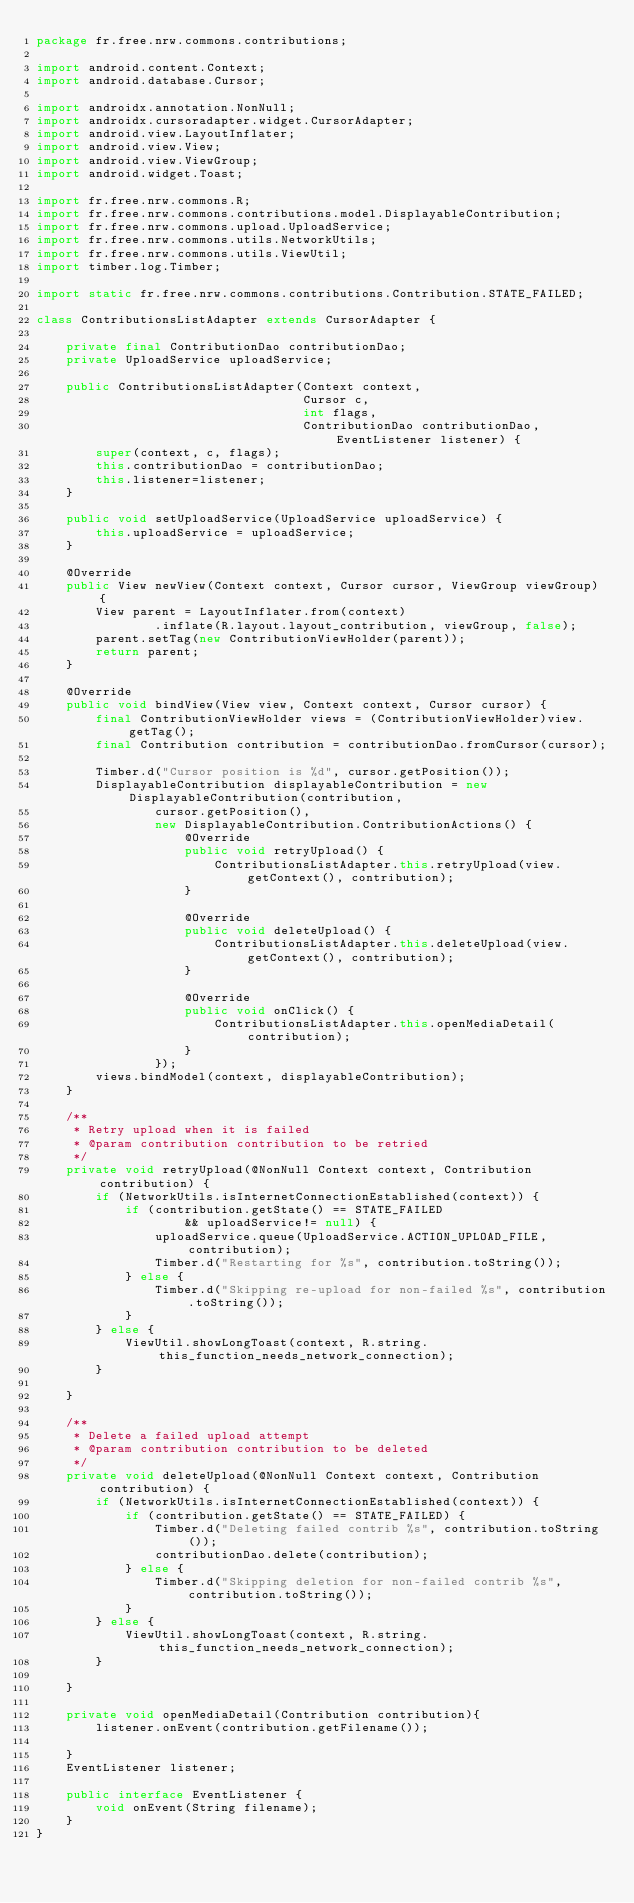<code> <loc_0><loc_0><loc_500><loc_500><_Java_>package fr.free.nrw.commons.contributions;

import android.content.Context;
import android.database.Cursor;

import androidx.annotation.NonNull;
import androidx.cursoradapter.widget.CursorAdapter;
import android.view.LayoutInflater;
import android.view.View;
import android.view.ViewGroup;
import android.widget.Toast;

import fr.free.nrw.commons.R;
import fr.free.nrw.commons.contributions.model.DisplayableContribution;
import fr.free.nrw.commons.upload.UploadService;
import fr.free.nrw.commons.utils.NetworkUtils;
import fr.free.nrw.commons.utils.ViewUtil;
import timber.log.Timber;

import static fr.free.nrw.commons.contributions.Contribution.STATE_FAILED;

class ContributionsListAdapter extends CursorAdapter {

    private final ContributionDao contributionDao;
    private UploadService uploadService;

    public ContributionsListAdapter(Context context,
                                    Cursor c,
                                    int flags,
                                    ContributionDao contributionDao, EventListener listener) {
        super(context, c, flags);
        this.contributionDao = contributionDao;
        this.listener=listener;
    }

    public void setUploadService(UploadService uploadService) {
        this.uploadService = uploadService;
    }

    @Override
    public View newView(Context context, Cursor cursor, ViewGroup viewGroup) {
        View parent = LayoutInflater.from(context)
                .inflate(R.layout.layout_contribution, viewGroup, false);
        parent.setTag(new ContributionViewHolder(parent));
        return parent;
    }

    @Override
    public void bindView(View view, Context context, Cursor cursor) {
        final ContributionViewHolder views = (ContributionViewHolder)view.getTag();
        final Contribution contribution = contributionDao.fromCursor(cursor);

        Timber.d("Cursor position is %d", cursor.getPosition());
        DisplayableContribution displayableContribution = new DisplayableContribution(contribution,
                cursor.getPosition(),
                new DisplayableContribution.ContributionActions() {
                    @Override
                    public void retryUpload() {
                        ContributionsListAdapter.this.retryUpload(view.getContext(), contribution);
                    }

                    @Override
                    public void deleteUpload() {
                        ContributionsListAdapter.this.deleteUpload(view.getContext(), contribution);
                    }

                    @Override
                    public void onClick() {
                        ContributionsListAdapter.this.openMediaDetail(contribution);
                    }
                });
        views.bindModel(context, displayableContribution);
    }

    /**
     * Retry upload when it is failed
     * @param contribution contribution to be retried
     */
    private void retryUpload(@NonNull Context context, Contribution contribution) {
        if (NetworkUtils.isInternetConnectionEstablished(context)) {
            if (contribution.getState() == STATE_FAILED
                    && uploadService!= null) {
                uploadService.queue(UploadService.ACTION_UPLOAD_FILE, contribution);
                Timber.d("Restarting for %s", contribution.toString());
            } else {
                Timber.d("Skipping re-upload for non-failed %s", contribution.toString());
            }
        } else {
            ViewUtil.showLongToast(context, R.string.this_function_needs_network_connection);
        }

    }

    /**
     * Delete a failed upload attempt
     * @param contribution contribution to be deleted
     */
    private void deleteUpload(@NonNull Context context, Contribution contribution) {
        if (NetworkUtils.isInternetConnectionEstablished(context)) {
            if (contribution.getState() == STATE_FAILED) {
                Timber.d("Deleting failed contrib %s", contribution.toString());
                contributionDao.delete(contribution);
            } else {
                Timber.d("Skipping deletion for non-failed contrib %s", contribution.toString());
            }
        } else {
            ViewUtil.showLongToast(context, R.string.this_function_needs_network_connection);
        }

    }

    private void openMediaDetail(Contribution contribution){
        listener.onEvent(contribution.getFilename());

    }
    EventListener listener;

    public interface EventListener {
        void onEvent(String filename);
    }
}
</code> 